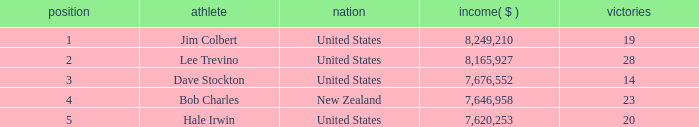How many average wins for players ranked below 2 with earnings greater than $7,676,552? None. 